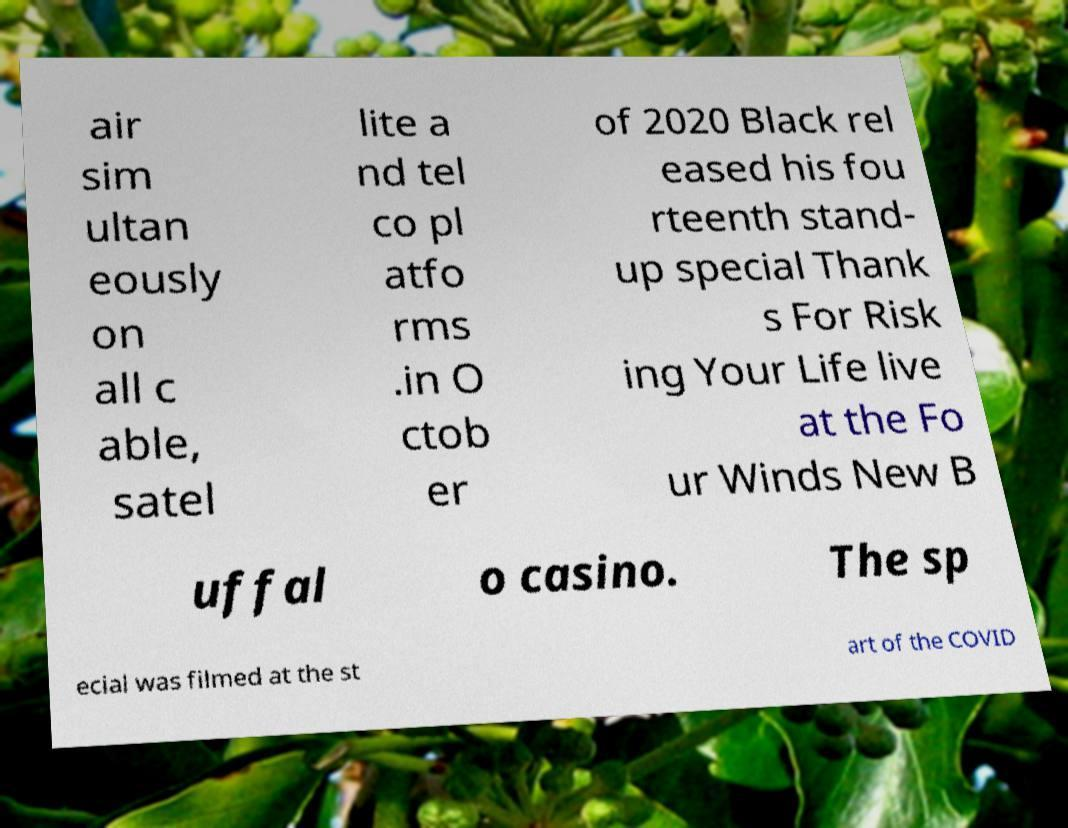Can you accurately transcribe the text from the provided image for me? air sim ultan eously on all c able, satel lite a nd tel co pl atfo rms .in O ctob er of 2020 Black rel eased his fou rteenth stand- up special Thank s For Risk ing Your Life live at the Fo ur Winds New B uffal o casino. The sp ecial was filmed at the st art of the COVID 